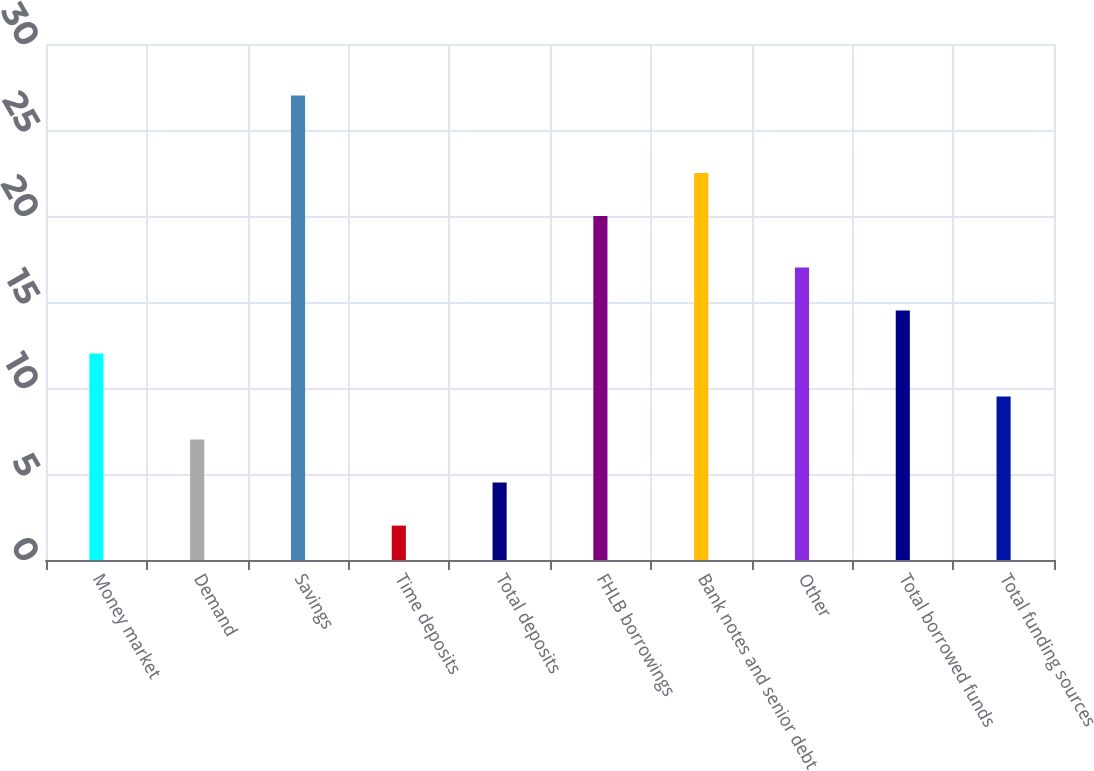Convert chart to OTSL. <chart><loc_0><loc_0><loc_500><loc_500><bar_chart><fcel>Money market<fcel>Demand<fcel>Savings<fcel>Time deposits<fcel>Total deposits<fcel>FHLB borrowings<fcel>Bank notes and senior debt<fcel>Other<fcel>Total borrowed funds<fcel>Total funding sources<nl><fcel>12<fcel>7<fcel>27<fcel>2<fcel>4.5<fcel>20<fcel>22.5<fcel>17<fcel>14.5<fcel>9.5<nl></chart> 